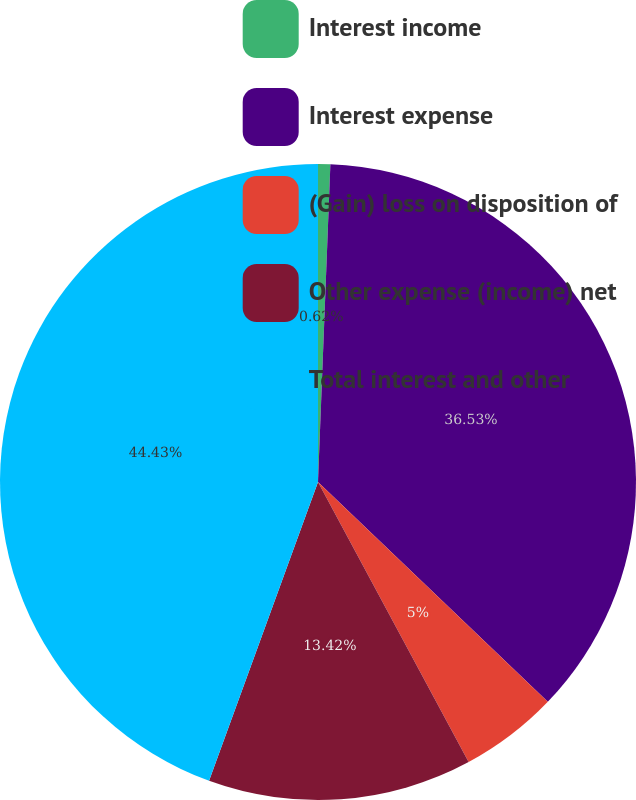Convert chart. <chart><loc_0><loc_0><loc_500><loc_500><pie_chart><fcel>Interest income<fcel>Interest expense<fcel>(Gain) loss on disposition of<fcel>Other expense (income) net<fcel>Total interest and other<nl><fcel>0.62%<fcel>36.53%<fcel>5.0%<fcel>13.42%<fcel>44.44%<nl></chart> 